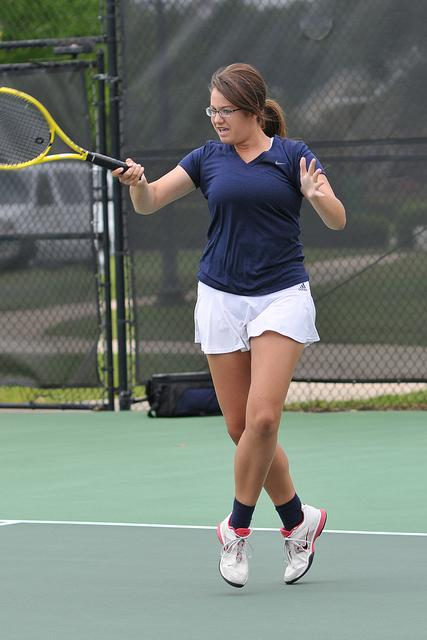What brand skirt she worn? adidas 